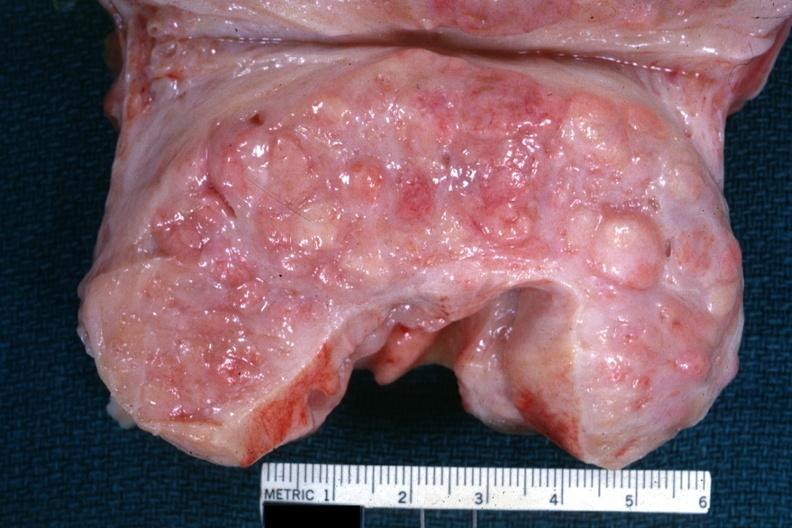s excellent example cut surface with nodular hyperplasia?
Answer the question using a single word or phrase. Yes 